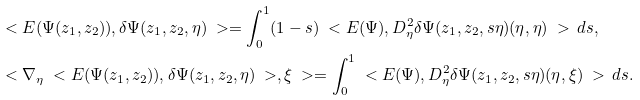Convert formula to latex. <formula><loc_0><loc_0><loc_500><loc_500>& \ < E ( \Psi ( z _ { 1 } , z _ { 2 } ) ) , \delta \Psi ( z _ { 1 } , z _ { 2 } , \eta ) \ > = \int _ { 0 } ^ { 1 } ( 1 - s ) \ < E ( \Psi ) , D _ { \eta } ^ { 2 } \delta \Psi ( z _ { 1 } , z _ { 2 } , s \eta ) ( \eta , \eta ) \ > \, d s , \\ & \ < \nabla _ { \eta } \ < E ( \Psi ( z _ { 1 } , z _ { 2 } ) ) , \delta \Psi ( z _ { 1 } , z _ { 2 } , \eta ) \ > , \xi \ > = \int _ { 0 } ^ { 1 } \ < E ( \Psi ) , D _ { \eta } ^ { 2 } \delta \Psi ( z _ { 1 } , z _ { 2 } , s \eta ) ( \eta , \xi ) \ > \, d s .</formula> 